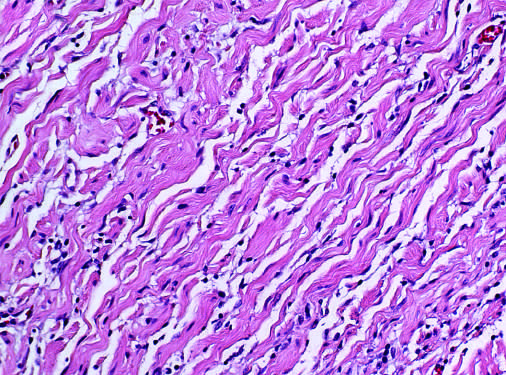what is likened to carrot shavings?
Answer the question using a single word or phrase. Collagen bundles 